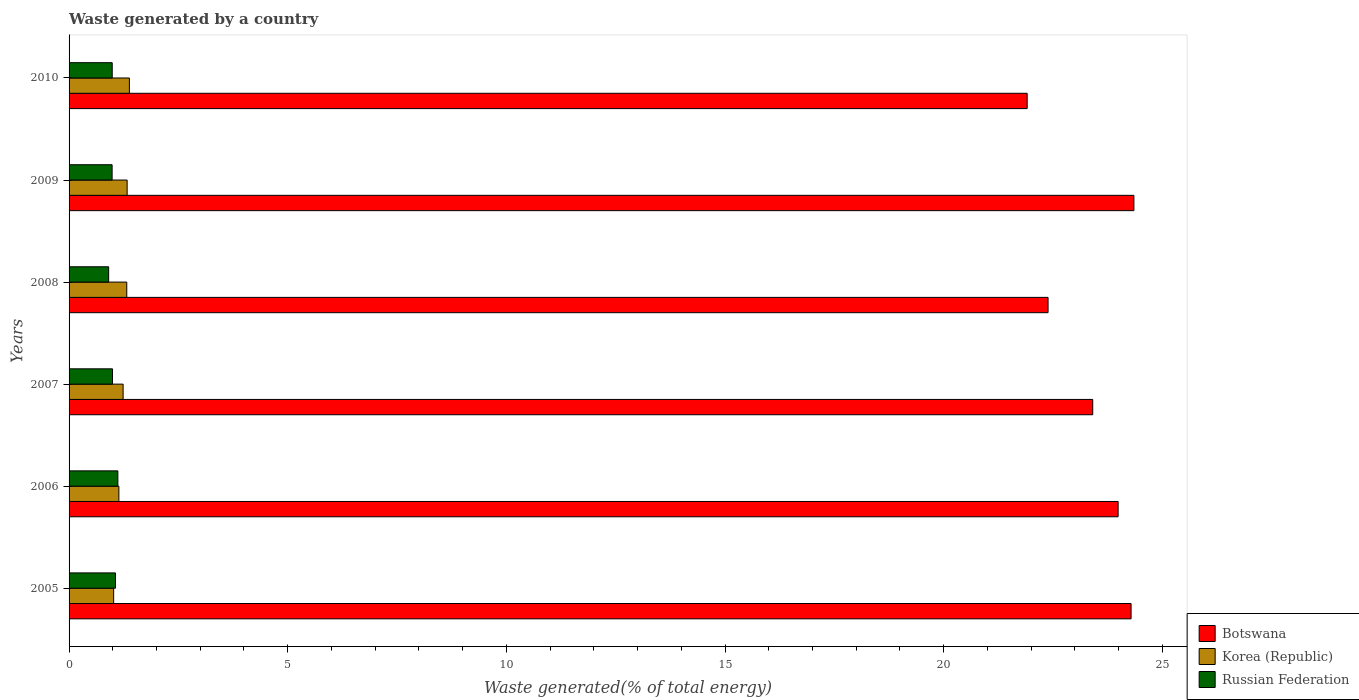Are the number of bars per tick equal to the number of legend labels?
Ensure brevity in your answer.  Yes. Are the number of bars on each tick of the Y-axis equal?
Your response must be concise. Yes. How many bars are there on the 4th tick from the bottom?
Give a very brief answer. 3. What is the total waste generated in Botswana in 2007?
Provide a succinct answer. 23.41. Across all years, what is the maximum total waste generated in Russian Federation?
Provide a short and direct response. 1.12. Across all years, what is the minimum total waste generated in Korea (Republic)?
Your answer should be compact. 1.02. In which year was the total waste generated in Korea (Republic) minimum?
Offer a terse response. 2005. What is the total total waste generated in Russian Federation in the graph?
Offer a terse response. 6.05. What is the difference between the total waste generated in Russian Federation in 2007 and that in 2009?
Ensure brevity in your answer.  0.01. What is the difference between the total waste generated in Russian Federation in 2005 and the total waste generated in Korea (Republic) in 2008?
Offer a terse response. -0.26. What is the average total waste generated in Botswana per year?
Your answer should be very brief. 23.39. In the year 2005, what is the difference between the total waste generated in Russian Federation and total waste generated in Korea (Republic)?
Give a very brief answer. 0.04. What is the ratio of the total waste generated in Botswana in 2008 to that in 2010?
Provide a succinct answer. 1.02. What is the difference between the highest and the second highest total waste generated in Russian Federation?
Offer a very short reply. 0.05. What is the difference between the highest and the lowest total waste generated in Russian Federation?
Provide a succinct answer. 0.21. Is the sum of the total waste generated in Korea (Republic) in 2008 and 2009 greater than the maximum total waste generated in Botswana across all years?
Your answer should be compact. No. What does the 1st bar from the bottom in 2009 represents?
Offer a terse response. Botswana. How many bars are there?
Your answer should be very brief. 18. Are all the bars in the graph horizontal?
Offer a very short reply. Yes. How many years are there in the graph?
Your answer should be very brief. 6. What is the difference between two consecutive major ticks on the X-axis?
Your response must be concise. 5. Does the graph contain any zero values?
Your answer should be very brief. No. Does the graph contain grids?
Keep it short and to the point. No. Where does the legend appear in the graph?
Your answer should be compact. Bottom right. How are the legend labels stacked?
Ensure brevity in your answer.  Vertical. What is the title of the graph?
Provide a succinct answer. Waste generated by a country. Does "Low income" appear as one of the legend labels in the graph?
Your response must be concise. No. What is the label or title of the X-axis?
Your answer should be very brief. Waste generated(% of total energy). What is the label or title of the Y-axis?
Your response must be concise. Years. What is the Waste generated(% of total energy) of Botswana in 2005?
Keep it short and to the point. 24.29. What is the Waste generated(% of total energy) of Korea (Republic) in 2005?
Offer a very short reply. 1.02. What is the Waste generated(% of total energy) in Russian Federation in 2005?
Your answer should be compact. 1.06. What is the Waste generated(% of total energy) in Botswana in 2006?
Provide a succinct answer. 23.99. What is the Waste generated(% of total energy) in Korea (Republic) in 2006?
Your answer should be compact. 1.14. What is the Waste generated(% of total energy) of Russian Federation in 2006?
Offer a very short reply. 1.12. What is the Waste generated(% of total energy) of Botswana in 2007?
Your answer should be very brief. 23.41. What is the Waste generated(% of total energy) in Korea (Republic) in 2007?
Make the answer very short. 1.24. What is the Waste generated(% of total energy) of Russian Federation in 2007?
Give a very brief answer. 0.99. What is the Waste generated(% of total energy) in Botswana in 2008?
Ensure brevity in your answer.  22.39. What is the Waste generated(% of total energy) of Korea (Republic) in 2008?
Offer a terse response. 1.32. What is the Waste generated(% of total energy) in Russian Federation in 2008?
Keep it short and to the point. 0.91. What is the Waste generated(% of total energy) in Botswana in 2009?
Offer a very short reply. 24.35. What is the Waste generated(% of total energy) of Korea (Republic) in 2009?
Offer a terse response. 1.33. What is the Waste generated(% of total energy) in Russian Federation in 2009?
Offer a terse response. 0.98. What is the Waste generated(% of total energy) of Botswana in 2010?
Provide a succinct answer. 21.91. What is the Waste generated(% of total energy) of Korea (Republic) in 2010?
Give a very brief answer. 1.38. What is the Waste generated(% of total energy) of Russian Federation in 2010?
Make the answer very short. 0.99. Across all years, what is the maximum Waste generated(% of total energy) in Botswana?
Provide a short and direct response. 24.35. Across all years, what is the maximum Waste generated(% of total energy) of Korea (Republic)?
Your answer should be very brief. 1.38. Across all years, what is the maximum Waste generated(% of total energy) of Russian Federation?
Offer a terse response. 1.12. Across all years, what is the minimum Waste generated(% of total energy) of Botswana?
Ensure brevity in your answer.  21.91. Across all years, what is the minimum Waste generated(% of total energy) in Korea (Republic)?
Provide a short and direct response. 1.02. Across all years, what is the minimum Waste generated(% of total energy) of Russian Federation?
Give a very brief answer. 0.91. What is the total Waste generated(% of total energy) of Botswana in the graph?
Your response must be concise. 140.33. What is the total Waste generated(% of total energy) of Korea (Republic) in the graph?
Your answer should be compact. 7.42. What is the total Waste generated(% of total energy) of Russian Federation in the graph?
Make the answer very short. 6.05. What is the difference between the Waste generated(% of total energy) of Botswana in 2005 and that in 2006?
Make the answer very short. 0.3. What is the difference between the Waste generated(% of total energy) of Korea (Republic) in 2005 and that in 2006?
Offer a terse response. -0.12. What is the difference between the Waste generated(% of total energy) in Russian Federation in 2005 and that in 2006?
Your response must be concise. -0.05. What is the difference between the Waste generated(% of total energy) of Botswana in 2005 and that in 2007?
Keep it short and to the point. 0.88. What is the difference between the Waste generated(% of total energy) in Korea (Republic) in 2005 and that in 2007?
Provide a succinct answer. -0.22. What is the difference between the Waste generated(% of total energy) in Russian Federation in 2005 and that in 2007?
Offer a terse response. 0.07. What is the difference between the Waste generated(% of total energy) in Botswana in 2005 and that in 2008?
Ensure brevity in your answer.  1.9. What is the difference between the Waste generated(% of total energy) in Korea (Republic) in 2005 and that in 2008?
Keep it short and to the point. -0.3. What is the difference between the Waste generated(% of total energy) of Russian Federation in 2005 and that in 2008?
Make the answer very short. 0.16. What is the difference between the Waste generated(% of total energy) in Botswana in 2005 and that in 2009?
Give a very brief answer. -0.06. What is the difference between the Waste generated(% of total energy) of Korea (Republic) in 2005 and that in 2009?
Keep it short and to the point. -0.31. What is the difference between the Waste generated(% of total energy) of Russian Federation in 2005 and that in 2009?
Your response must be concise. 0.08. What is the difference between the Waste generated(% of total energy) in Botswana in 2005 and that in 2010?
Ensure brevity in your answer.  2.38. What is the difference between the Waste generated(% of total energy) of Korea (Republic) in 2005 and that in 2010?
Your answer should be compact. -0.36. What is the difference between the Waste generated(% of total energy) in Russian Federation in 2005 and that in 2010?
Ensure brevity in your answer.  0.07. What is the difference between the Waste generated(% of total energy) in Botswana in 2006 and that in 2007?
Ensure brevity in your answer.  0.58. What is the difference between the Waste generated(% of total energy) in Korea (Republic) in 2006 and that in 2007?
Offer a very short reply. -0.1. What is the difference between the Waste generated(% of total energy) of Russian Federation in 2006 and that in 2007?
Provide a short and direct response. 0.12. What is the difference between the Waste generated(% of total energy) of Botswana in 2006 and that in 2008?
Ensure brevity in your answer.  1.6. What is the difference between the Waste generated(% of total energy) in Korea (Republic) in 2006 and that in 2008?
Offer a very short reply. -0.18. What is the difference between the Waste generated(% of total energy) of Russian Federation in 2006 and that in 2008?
Ensure brevity in your answer.  0.21. What is the difference between the Waste generated(% of total energy) in Botswana in 2006 and that in 2009?
Your answer should be very brief. -0.36. What is the difference between the Waste generated(% of total energy) of Korea (Republic) in 2006 and that in 2009?
Your answer should be compact. -0.19. What is the difference between the Waste generated(% of total energy) in Russian Federation in 2006 and that in 2009?
Make the answer very short. 0.13. What is the difference between the Waste generated(% of total energy) in Botswana in 2006 and that in 2010?
Your answer should be very brief. 2.08. What is the difference between the Waste generated(% of total energy) in Korea (Republic) in 2006 and that in 2010?
Provide a succinct answer. -0.24. What is the difference between the Waste generated(% of total energy) in Russian Federation in 2006 and that in 2010?
Provide a short and direct response. 0.13. What is the difference between the Waste generated(% of total energy) in Botswana in 2007 and that in 2008?
Provide a short and direct response. 1.02. What is the difference between the Waste generated(% of total energy) of Korea (Republic) in 2007 and that in 2008?
Provide a short and direct response. -0.08. What is the difference between the Waste generated(% of total energy) in Russian Federation in 2007 and that in 2008?
Your answer should be compact. 0.09. What is the difference between the Waste generated(% of total energy) in Botswana in 2007 and that in 2009?
Make the answer very short. -0.94. What is the difference between the Waste generated(% of total energy) of Korea (Republic) in 2007 and that in 2009?
Provide a succinct answer. -0.09. What is the difference between the Waste generated(% of total energy) of Russian Federation in 2007 and that in 2009?
Provide a succinct answer. 0.01. What is the difference between the Waste generated(% of total energy) of Botswana in 2007 and that in 2010?
Your response must be concise. 1.5. What is the difference between the Waste generated(% of total energy) in Korea (Republic) in 2007 and that in 2010?
Provide a short and direct response. -0.14. What is the difference between the Waste generated(% of total energy) of Russian Federation in 2007 and that in 2010?
Your response must be concise. 0.01. What is the difference between the Waste generated(% of total energy) in Botswana in 2008 and that in 2009?
Give a very brief answer. -1.96. What is the difference between the Waste generated(% of total energy) of Korea (Republic) in 2008 and that in 2009?
Your answer should be compact. -0.01. What is the difference between the Waste generated(% of total energy) of Russian Federation in 2008 and that in 2009?
Offer a terse response. -0.08. What is the difference between the Waste generated(% of total energy) in Botswana in 2008 and that in 2010?
Your response must be concise. 0.48. What is the difference between the Waste generated(% of total energy) in Korea (Republic) in 2008 and that in 2010?
Keep it short and to the point. -0.06. What is the difference between the Waste generated(% of total energy) in Russian Federation in 2008 and that in 2010?
Your response must be concise. -0.08. What is the difference between the Waste generated(% of total energy) of Botswana in 2009 and that in 2010?
Your response must be concise. 2.44. What is the difference between the Waste generated(% of total energy) in Korea (Republic) in 2009 and that in 2010?
Provide a short and direct response. -0.05. What is the difference between the Waste generated(% of total energy) in Russian Federation in 2009 and that in 2010?
Offer a terse response. -0. What is the difference between the Waste generated(% of total energy) of Botswana in 2005 and the Waste generated(% of total energy) of Korea (Republic) in 2006?
Make the answer very short. 23.15. What is the difference between the Waste generated(% of total energy) in Botswana in 2005 and the Waste generated(% of total energy) in Russian Federation in 2006?
Your answer should be very brief. 23.17. What is the difference between the Waste generated(% of total energy) of Korea (Republic) in 2005 and the Waste generated(% of total energy) of Russian Federation in 2006?
Ensure brevity in your answer.  -0.1. What is the difference between the Waste generated(% of total energy) in Botswana in 2005 and the Waste generated(% of total energy) in Korea (Republic) in 2007?
Your answer should be compact. 23.05. What is the difference between the Waste generated(% of total energy) of Botswana in 2005 and the Waste generated(% of total energy) of Russian Federation in 2007?
Offer a terse response. 23.29. What is the difference between the Waste generated(% of total energy) of Korea (Republic) in 2005 and the Waste generated(% of total energy) of Russian Federation in 2007?
Your answer should be compact. 0.03. What is the difference between the Waste generated(% of total energy) of Botswana in 2005 and the Waste generated(% of total energy) of Korea (Republic) in 2008?
Make the answer very short. 22.97. What is the difference between the Waste generated(% of total energy) in Botswana in 2005 and the Waste generated(% of total energy) in Russian Federation in 2008?
Provide a short and direct response. 23.38. What is the difference between the Waste generated(% of total energy) in Korea (Republic) in 2005 and the Waste generated(% of total energy) in Russian Federation in 2008?
Your answer should be very brief. 0.11. What is the difference between the Waste generated(% of total energy) of Botswana in 2005 and the Waste generated(% of total energy) of Korea (Republic) in 2009?
Ensure brevity in your answer.  22.96. What is the difference between the Waste generated(% of total energy) in Botswana in 2005 and the Waste generated(% of total energy) in Russian Federation in 2009?
Provide a short and direct response. 23.3. What is the difference between the Waste generated(% of total energy) in Korea (Republic) in 2005 and the Waste generated(% of total energy) in Russian Federation in 2009?
Your answer should be very brief. 0.04. What is the difference between the Waste generated(% of total energy) of Botswana in 2005 and the Waste generated(% of total energy) of Korea (Republic) in 2010?
Keep it short and to the point. 22.91. What is the difference between the Waste generated(% of total energy) in Botswana in 2005 and the Waste generated(% of total energy) in Russian Federation in 2010?
Offer a terse response. 23.3. What is the difference between the Waste generated(% of total energy) in Korea (Republic) in 2005 and the Waste generated(% of total energy) in Russian Federation in 2010?
Offer a terse response. 0.03. What is the difference between the Waste generated(% of total energy) of Botswana in 2006 and the Waste generated(% of total energy) of Korea (Republic) in 2007?
Provide a short and direct response. 22.75. What is the difference between the Waste generated(% of total energy) of Botswana in 2006 and the Waste generated(% of total energy) of Russian Federation in 2007?
Offer a very short reply. 23. What is the difference between the Waste generated(% of total energy) of Korea (Republic) in 2006 and the Waste generated(% of total energy) of Russian Federation in 2007?
Offer a very short reply. 0.15. What is the difference between the Waste generated(% of total energy) in Botswana in 2006 and the Waste generated(% of total energy) in Korea (Republic) in 2008?
Give a very brief answer. 22.67. What is the difference between the Waste generated(% of total energy) of Botswana in 2006 and the Waste generated(% of total energy) of Russian Federation in 2008?
Ensure brevity in your answer.  23.08. What is the difference between the Waste generated(% of total energy) in Korea (Republic) in 2006 and the Waste generated(% of total energy) in Russian Federation in 2008?
Provide a short and direct response. 0.23. What is the difference between the Waste generated(% of total energy) in Botswana in 2006 and the Waste generated(% of total energy) in Korea (Republic) in 2009?
Ensure brevity in your answer.  22.66. What is the difference between the Waste generated(% of total energy) of Botswana in 2006 and the Waste generated(% of total energy) of Russian Federation in 2009?
Provide a succinct answer. 23.01. What is the difference between the Waste generated(% of total energy) of Korea (Republic) in 2006 and the Waste generated(% of total energy) of Russian Federation in 2009?
Ensure brevity in your answer.  0.15. What is the difference between the Waste generated(% of total energy) of Botswana in 2006 and the Waste generated(% of total energy) of Korea (Republic) in 2010?
Your response must be concise. 22.61. What is the difference between the Waste generated(% of total energy) in Botswana in 2006 and the Waste generated(% of total energy) in Russian Federation in 2010?
Provide a succinct answer. 23. What is the difference between the Waste generated(% of total energy) of Korea (Republic) in 2006 and the Waste generated(% of total energy) of Russian Federation in 2010?
Give a very brief answer. 0.15. What is the difference between the Waste generated(% of total energy) in Botswana in 2007 and the Waste generated(% of total energy) in Korea (Republic) in 2008?
Keep it short and to the point. 22.09. What is the difference between the Waste generated(% of total energy) in Botswana in 2007 and the Waste generated(% of total energy) in Russian Federation in 2008?
Keep it short and to the point. 22.5. What is the difference between the Waste generated(% of total energy) of Korea (Republic) in 2007 and the Waste generated(% of total energy) of Russian Federation in 2008?
Ensure brevity in your answer.  0.33. What is the difference between the Waste generated(% of total energy) of Botswana in 2007 and the Waste generated(% of total energy) of Korea (Republic) in 2009?
Give a very brief answer. 22.08. What is the difference between the Waste generated(% of total energy) of Botswana in 2007 and the Waste generated(% of total energy) of Russian Federation in 2009?
Your response must be concise. 22.43. What is the difference between the Waste generated(% of total energy) of Korea (Republic) in 2007 and the Waste generated(% of total energy) of Russian Federation in 2009?
Make the answer very short. 0.25. What is the difference between the Waste generated(% of total energy) of Botswana in 2007 and the Waste generated(% of total energy) of Korea (Republic) in 2010?
Your answer should be compact. 22.03. What is the difference between the Waste generated(% of total energy) of Botswana in 2007 and the Waste generated(% of total energy) of Russian Federation in 2010?
Provide a short and direct response. 22.42. What is the difference between the Waste generated(% of total energy) in Korea (Republic) in 2007 and the Waste generated(% of total energy) in Russian Federation in 2010?
Provide a short and direct response. 0.25. What is the difference between the Waste generated(% of total energy) in Botswana in 2008 and the Waste generated(% of total energy) in Korea (Republic) in 2009?
Your answer should be very brief. 21.06. What is the difference between the Waste generated(% of total energy) of Botswana in 2008 and the Waste generated(% of total energy) of Russian Federation in 2009?
Offer a terse response. 21.4. What is the difference between the Waste generated(% of total energy) of Korea (Republic) in 2008 and the Waste generated(% of total energy) of Russian Federation in 2009?
Keep it short and to the point. 0.34. What is the difference between the Waste generated(% of total energy) in Botswana in 2008 and the Waste generated(% of total energy) in Korea (Republic) in 2010?
Make the answer very short. 21.01. What is the difference between the Waste generated(% of total energy) in Botswana in 2008 and the Waste generated(% of total energy) in Russian Federation in 2010?
Offer a very short reply. 21.4. What is the difference between the Waste generated(% of total energy) in Korea (Republic) in 2008 and the Waste generated(% of total energy) in Russian Federation in 2010?
Provide a succinct answer. 0.33. What is the difference between the Waste generated(% of total energy) of Botswana in 2009 and the Waste generated(% of total energy) of Korea (Republic) in 2010?
Provide a succinct answer. 22.97. What is the difference between the Waste generated(% of total energy) of Botswana in 2009 and the Waste generated(% of total energy) of Russian Federation in 2010?
Your answer should be compact. 23.36. What is the difference between the Waste generated(% of total energy) in Korea (Republic) in 2009 and the Waste generated(% of total energy) in Russian Federation in 2010?
Your answer should be very brief. 0.34. What is the average Waste generated(% of total energy) in Botswana per year?
Your answer should be very brief. 23.39. What is the average Waste generated(% of total energy) in Korea (Republic) per year?
Make the answer very short. 1.24. What is the average Waste generated(% of total energy) in Russian Federation per year?
Keep it short and to the point. 1.01. In the year 2005, what is the difference between the Waste generated(% of total energy) of Botswana and Waste generated(% of total energy) of Korea (Republic)?
Your answer should be compact. 23.27. In the year 2005, what is the difference between the Waste generated(% of total energy) of Botswana and Waste generated(% of total energy) of Russian Federation?
Your answer should be compact. 23.23. In the year 2005, what is the difference between the Waste generated(% of total energy) in Korea (Republic) and Waste generated(% of total energy) in Russian Federation?
Your response must be concise. -0.04. In the year 2006, what is the difference between the Waste generated(% of total energy) of Botswana and Waste generated(% of total energy) of Korea (Republic)?
Offer a very short reply. 22.85. In the year 2006, what is the difference between the Waste generated(% of total energy) of Botswana and Waste generated(% of total energy) of Russian Federation?
Ensure brevity in your answer.  22.87. In the year 2006, what is the difference between the Waste generated(% of total energy) of Korea (Republic) and Waste generated(% of total energy) of Russian Federation?
Provide a succinct answer. 0.02. In the year 2007, what is the difference between the Waste generated(% of total energy) of Botswana and Waste generated(% of total energy) of Korea (Republic)?
Keep it short and to the point. 22.17. In the year 2007, what is the difference between the Waste generated(% of total energy) in Botswana and Waste generated(% of total energy) in Russian Federation?
Offer a terse response. 22.42. In the year 2007, what is the difference between the Waste generated(% of total energy) in Korea (Republic) and Waste generated(% of total energy) in Russian Federation?
Provide a succinct answer. 0.24. In the year 2008, what is the difference between the Waste generated(% of total energy) in Botswana and Waste generated(% of total energy) in Korea (Republic)?
Make the answer very short. 21.07. In the year 2008, what is the difference between the Waste generated(% of total energy) of Botswana and Waste generated(% of total energy) of Russian Federation?
Offer a terse response. 21.48. In the year 2008, what is the difference between the Waste generated(% of total energy) of Korea (Republic) and Waste generated(% of total energy) of Russian Federation?
Make the answer very short. 0.41. In the year 2009, what is the difference between the Waste generated(% of total energy) of Botswana and Waste generated(% of total energy) of Korea (Republic)?
Keep it short and to the point. 23.02. In the year 2009, what is the difference between the Waste generated(% of total energy) in Botswana and Waste generated(% of total energy) in Russian Federation?
Offer a very short reply. 23.37. In the year 2009, what is the difference between the Waste generated(% of total energy) of Korea (Republic) and Waste generated(% of total energy) of Russian Federation?
Offer a very short reply. 0.34. In the year 2010, what is the difference between the Waste generated(% of total energy) in Botswana and Waste generated(% of total energy) in Korea (Republic)?
Keep it short and to the point. 20.53. In the year 2010, what is the difference between the Waste generated(% of total energy) of Botswana and Waste generated(% of total energy) of Russian Federation?
Provide a short and direct response. 20.92. In the year 2010, what is the difference between the Waste generated(% of total energy) of Korea (Republic) and Waste generated(% of total energy) of Russian Federation?
Keep it short and to the point. 0.39. What is the ratio of the Waste generated(% of total energy) of Botswana in 2005 to that in 2006?
Provide a succinct answer. 1.01. What is the ratio of the Waste generated(% of total energy) of Korea (Republic) in 2005 to that in 2006?
Offer a very short reply. 0.9. What is the ratio of the Waste generated(% of total energy) in Russian Federation in 2005 to that in 2006?
Your answer should be very brief. 0.95. What is the ratio of the Waste generated(% of total energy) in Botswana in 2005 to that in 2007?
Make the answer very short. 1.04. What is the ratio of the Waste generated(% of total energy) in Korea (Republic) in 2005 to that in 2007?
Make the answer very short. 0.82. What is the ratio of the Waste generated(% of total energy) in Russian Federation in 2005 to that in 2007?
Keep it short and to the point. 1.07. What is the ratio of the Waste generated(% of total energy) of Botswana in 2005 to that in 2008?
Your response must be concise. 1.08. What is the ratio of the Waste generated(% of total energy) of Korea (Republic) in 2005 to that in 2008?
Provide a short and direct response. 0.77. What is the ratio of the Waste generated(% of total energy) in Russian Federation in 2005 to that in 2008?
Offer a very short reply. 1.17. What is the ratio of the Waste generated(% of total energy) of Botswana in 2005 to that in 2009?
Provide a short and direct response. 1. What is the ratio of the Waste generated(% of total energy) of Korea (Republic) in 2005 to that in 2009?
Provide a short and direct response. 0.77. What is the ratio of the Waste generated(% of total energy) in Russian Federation in 2005 to that in 2009?
Give a very brief answer. 1.08. What is the ratio of the Waste generated(% of total energy) of Botswana in 2005 to that in 2010?
Your answer should be compact. 1.11. What is the ratio of the Waste generated(% of total energy) in Korea (Republic) in 2005 to that in 2010?
Provide a succinct answer. 0.74. What is the ratio of the Waste generated(% of total energy) in Russian Federation in 2005 to that in 2010?
Your answer should be very brief. 1.08. What is the ratio of the Waste generated(% of total energy) in Botswana in 2006 to that in 2007?
Provide a succinct answer. 1.02. What is the ratio of the Waste generated(% of total energy) in Korea (Republic) in 2006 to that in 2007?
Provide a short and direct response. 0.92. What is the ratio of the Waste generated(% of total energy) of Russian Federation in 2006 to that in 2007?
Offer a terse response. 1.12. What is the ratio of the Waste generated(% of total energy) in Botswana in 2006 to that in 2008?
Make the answer very short. 1.07. What is the ratio of the Waste generated(% of total energy) of Korea (Republic) in 2006 to that in 2008?
Provide a succinct answer. 0.86. What is the ratio of the Waste generated(% of total energy) in Russian Federation in 2006 to that in 2008?
Keep it short and to the point. 1.23. What is the ratio of the Waste generated(% of total energy) of Botswana in 2006 to that in 2009?
Offer a terse response. 0.99. What is the ratio of the Waste generated(% of total energy) of Korea (Republic) in 2006 to that in 2009?
Your response must be concise. 0.86. What is the ratio of the Waste generated(% of total energy) in Russian Federation in 2006 to that in 2009?
Offer a terse response. 1.13. What is the ratio of the Waste generated(% of total energy) in Botswana in 2006 to that in 2010?
Give a very brief answer. 1.09. What is the ratio of the Waste generated(% of total energy) in Korea (Republic) in 2006 to that in 2010?
Your answer should be compact. 0.83. What is the ratio of the Waste generated(% of total energy) in Russian Federation in 2006 to that in 2010?
Offer a very short reply. 1.13. What is the ratio of the Waste generated(% of total energy) of Botswana in 2007 to that in 2008?
Provide a succinct answer. 1.05. What is the ratio of the Waste generated(% of total energy) in Korea (Republic) in 2007 to that in 2008?
Your answer should be compact. 0.94. What is the ratio of the Waste generated(% of total energy) of Russian Federation in 2007 to that in 2008?
Your response must be concise. 1.1. What is the ratio of the Waste generated(% of total energy) of Botswana in 2007 to that in 2009?
Your answer should be very brief. 0.96. What is the ratio of the Waste generated(% of total energy) of Korea (Republic) in 2007 to that in 2009?
Offer a very short reply. 0.93. What is the ratio of the Waste generated(% of total energy) of Russian Federation in 2007 to that in 2009?
Your answer should be compact. 1.01. What is the ratio of the Waste generated(% of total energy) of Botswana in 2007 to that in 2010?
Your answer should be very brief. 1.07. What is the ratio of the Waste generated(% of total energy) in Korea (Republic) in 2007 to that in 2010?
Your answer should be compact. 0.9. What is the ratio of the Waste generated(% of total energy) of Russian Federation in 2007 to that in 2010?
Your answer should be compact. 1.01. What is the ratio of the Waste generated(% of total energy) of Botswana in 2008 to that in 2009?
Provide a succinct answer. 0.92. What is the ratio of the Waste generated(% of total energy) in Russian Federation in 2008 to that in 2009?
Your answer should be very brief. 0.92. What is the ratio of the Waste generated(% of total energy) of Botswana in 2008 to that in 2010?
Your answer should be compact. 1.02. What is the ratio of the Waste generated(% of total energy) of Korea (Republic) in 2008 to that in 2010?
Give a very brief answer. 0.96. What is the ratio of the Waste generated(% of total energy) in Russian Federation in 2008 to that in 2010?
Keep it short and to the point. 0.92. What is the ratio of the Waste generated(% of total energy) of Botswana in 2009 to that in 2010?
Your answer should be compact. 1.11. What is the ratio of the Waste generated(% of total energy) in Korea (Republic) in 2009 to that in 2010?
Provide a short and direct response. 0.96. What is the difference between the highest and the second highest Waste generated(% of total energy) in Botswana?
Ensure brevity in your answer.  0.06. What is the difference between the highest and the second highest Waste generated(% of total energy) of Korea (Republic)?
Provide a succinct answer. 0.05. What is the difference between the highest and the second highest Waste generated(% of total energy) of Russian Federation?
Offer a terse response. 0.05. What is the difference between the highest and the lowest Waste generated(% of total energy) in Botswana?
Keep it short and to the point. 2.44. What is the difference between the highest and the lowest Waste generated(% of total energy) of Korea (Republic)?
Offer a terse response. 0.36. What is the difference between the highest and the lowest Waste generated(% of total energy) in Russian Federation?
Offer a very short reply. 0.21. 